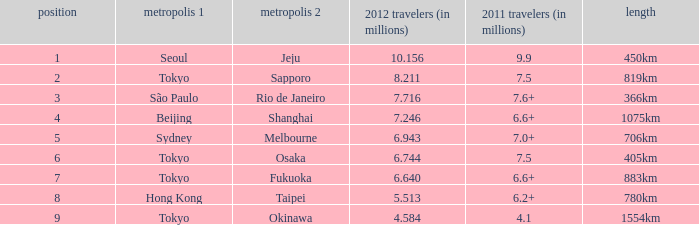6 million travelers? São Paulo. 